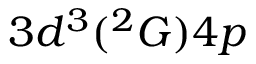<formula> <loc_0><loc_0><loc_500><loc_500>3 d ^ { 3 } ( ^ { 2 } G ) 4 p</formula> 